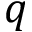<formula> <loc_0><loc_0><loc_500><loc_500>q</formula> 